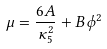Convert formula to latex. <formula><loc_0><loc_0><loc_500><loc_500>\mu = \frac { 6 A } { \kappa _ { 5 } ^ { 2 } } + B \phi ^ { 2 }</formula> 